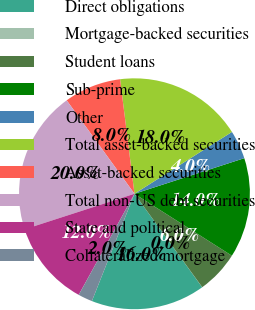<chart> <loc_0><loc_0><loc_500><loc_500><pie_chart><fcel>Direct obligations<fcel>Mortgage-backed securities<fcel>Student loans<fcel>Sub-prime<fcel>Other<fcel>Total asset-backed securities<fcel>Asset-backed securities<fcel>Total non-US debt securities<fcel>State and political<fcel>Collateralized mortgage<nl><fcel>15.99%<fcel>0.01%<fcel>6.0%<fcel>14.0%<fcel>4.01%<fcel>17.99%<fcel>8.0%<fcel>19.99%<fcel>12.0%<fcel>2.01%<nl></chart> 